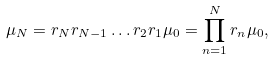Convert formula to latex. <formula><loc_0><loc_0><loc_500><loc_500>\mu _ { N } = { r } _ { N } { r } _ { N - 1 } \dots { r } _ { 2 } { r } _ { 1 } \mu _ { 0 } = \prod _ { n = 1 } ^ { N } { r } _ { n } \mu _ { 0 } ,</formula> 